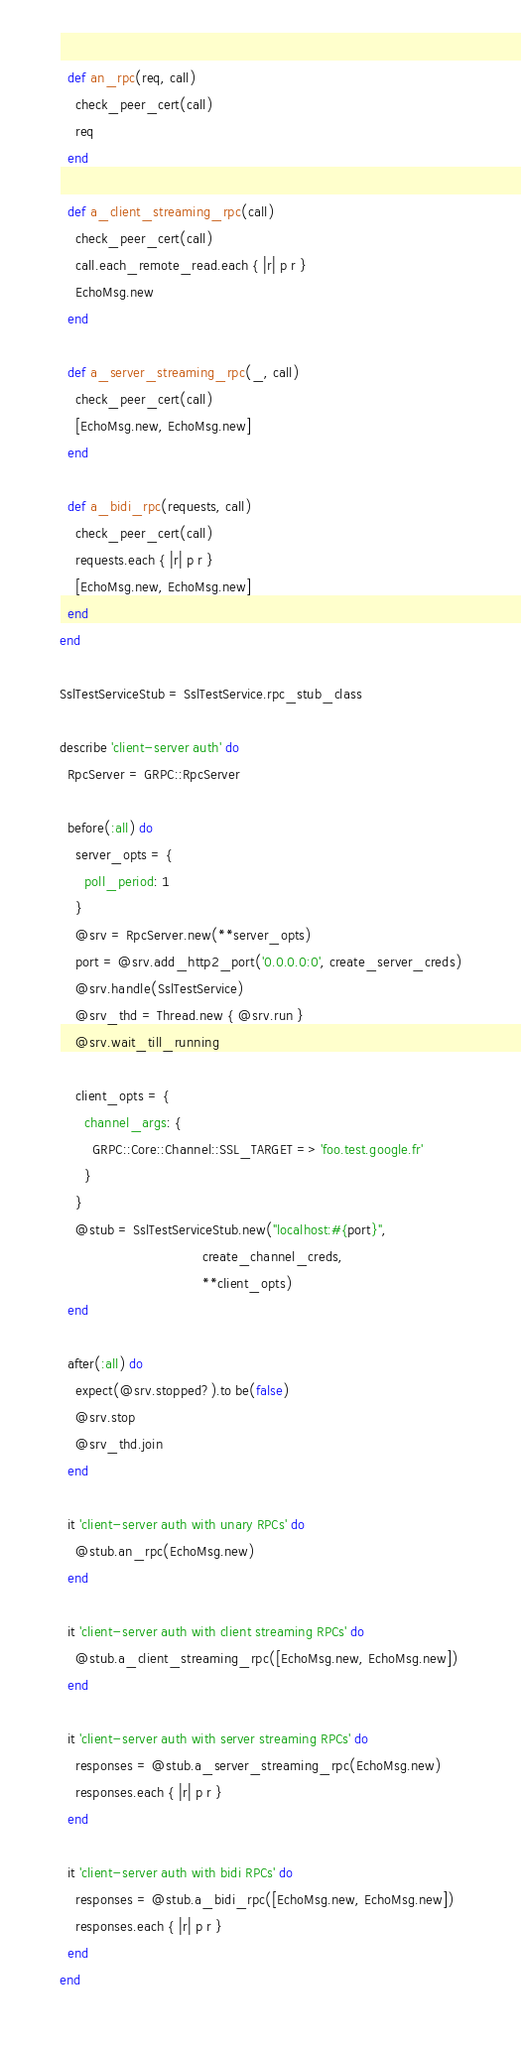Convert code to text. <code><loc_0><loc_0><loc_500><loc_500><_Ruby_>
  def an_rpc(req, call)
    check_peer_cert(call)
    req
  end

  def a_client_streaming_rpc(call)
    check_peer_cert(call)
    call.each_remote_read.each { |r| p r }
    EchoMsg.new
  end

  def a_server_streaming_rpc(_, call)
    check_peer_cert(call)
    [EchoMsg.new, EchoMsg.new]
  end

  def a_bidi_rpc(requests, call)
    check_peer_cert(call)
    requests.each { |r| p r }
    [EchoMsg.new, EchoMsg.new]
  end
end

SslTestServiceStub = SslTestService.rpc_stub_class

describe 'client-server auth' do
  RpcServer = GRPC::RpcServer

  before(:all) do
    server_opts = {
      poll_period: 1
    }
    @srv = RpcServer.new(**server_opts)
    port = @srv.add_http2_port('0.0.0.0:0', create_server_creds)
    @srv.handle(SslTestService)
    @srv_thd = Thread.new { @srv.run }
    @srv.wait_till_running

    client_opts = {
      channel_args: {
        GRPC::Core::Channel::SSL_TARGET => 'foo.test.google.fr'
      }
    }
    @stub = SslTestServiceStub.new("localhost:#{port}",
                                   create_channel_creds,
                                   **client_opts)
  end

  after(:all) do
    expect(@srv.stopped?).to be(false)
    @srv.stop
    @srv_thd.join
  end

  it 'client-server auth with unary RPCs' do
    @stub.an_rpc(EchoMsg.new)
  end

  it 'client-server auth with client streaming RPCs' do
    @stub.a_client_streaming_rpc([EchoMsg.new, EchoMsg.new])
  end

  it 'client-server auth with server streaming RPCs' do
    responses = @stub.a_server_streaming_rpc(EchoMsg.new)
    responses.each { |r| p r }
  end

  it 'client-server auth with bidi RPCs' do
    responses = @stub.a_bidi_rpc([EchoMsg.new, EchoMsg.new])
    responses.each { |r| p r }
  end
end
</code> 